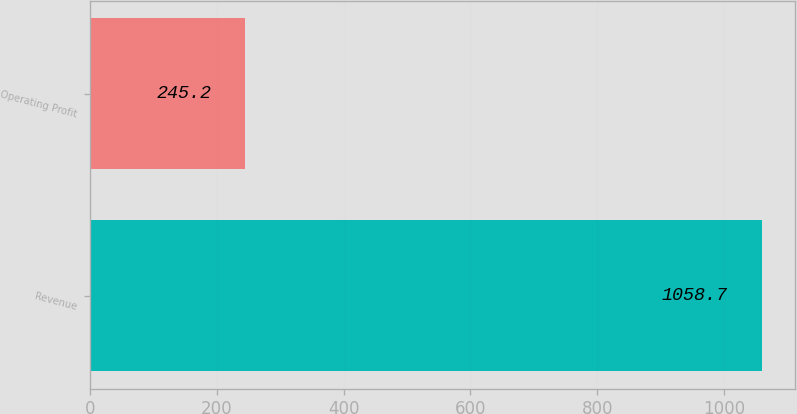Convert chart to OTSL. <chart><loc_0><loc_0><loc_500><loc_500><bar_chart><fcel>Revenue<fcel>Operating Profit<nl><fcel>1058.7<fcel>245.2<nl></chart> 